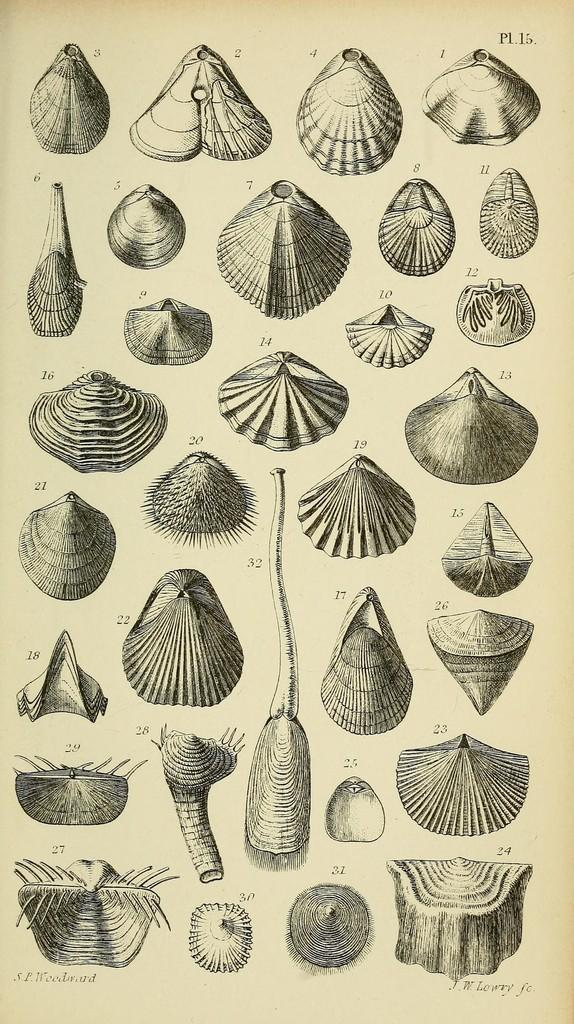What is depicted in the image? There are different types of shell pictures in the image. What is the medium on which the shell pictures are displayed? The shell pictures are on a paper. Where is the desk located in the image? There is no desk present in the image. What type of apple is shown in the image? There is no apple present in the image. How many books can be seen in the image? There are no books present in the image. 